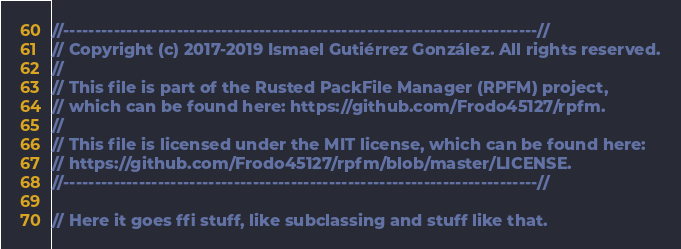Convert code to text. <code><loc_0><loc_0><loc_500><loc_500><_Rust_>//---------------------------------------------------------------------------//
// Copyright (c) 2017-2019 Ismael Gutiérrez González. All rights reserved.
// 
// This file is part of the Rusted PackFile Manager (RPFM) project,
// which can be found here: https://github.com/Frodo45127/rpfm.
// 
// This file is licensed under the MIT license, which can be found here:
// https://github.com/Frodo45127/rpfm/blob/master/LICENSE.
//---------------------------------------------------------------------------//

// Here it goes ffi stuff, like subclassing and stuff like that.
</code> 